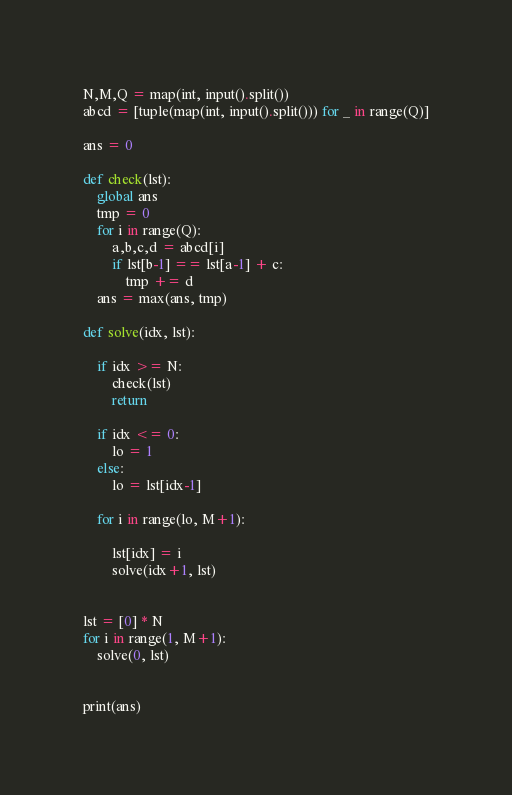<code> <loc_0><loc_0><loc_500><loc_500><_Python_>


N,M,Q = map(int, input().split())
abcd = [tuple(map(int, input().split())) for _ in range(Q)]

ans = 0

def check(lst):
    global ans
    tmp = 0
    for i in range(Q):
        a,b,c,d = abcd[i]
        if lst[b-1] == lst[a-1] + c:
            tmp += d
    ans = max(ans, tmp)

def solve(idx, lst):

    if idx >= N:
        check(lst)
        return
    
    if idx <= 0:
        lo = 1
    else:
        lo = lst[idx-1]

    for i in range(lo, M+1):
        
        lst[idx] = i
        solve(idx+1, lst)


lst = [0] * N
for i in range(1, M+1):
    solve(0, lst)
    

print(ans)</code> 